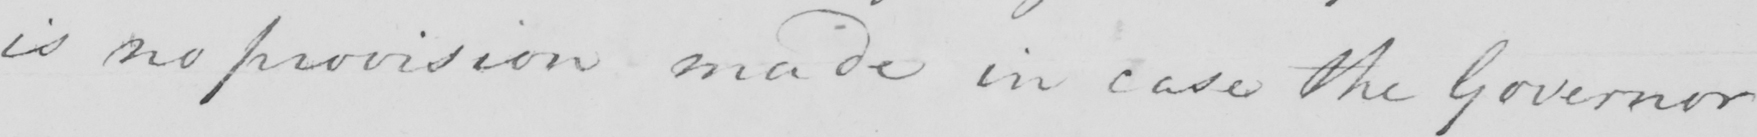Please provide the text content of this handwritten line. is no provision made in case the Governor 